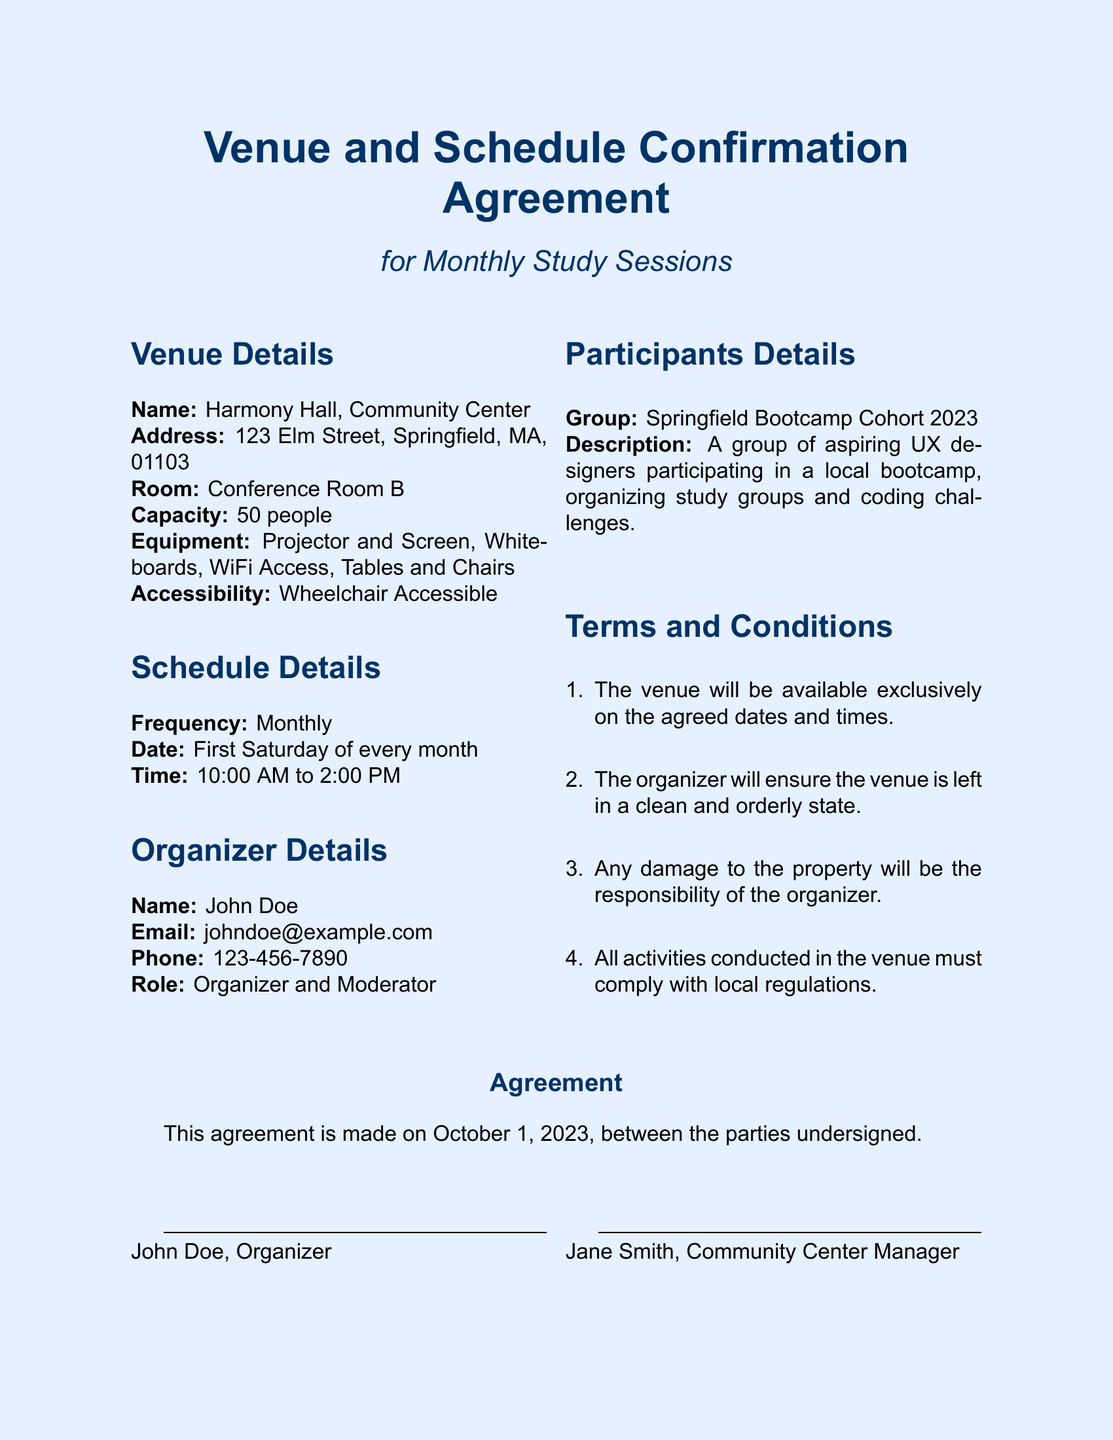What is the name of the venue? The venue name is mentioned in the Venue Details section of the document.
Answer: Harmony Hall What is the address of the venue? The address is specified in the Venue Details section.
Answer: 123 Elm Street, Springfield, MA, 01103 When are the study sessions scheduled? The schedule is detailed in the Schedule Details section, specifying the monthly frequency.
Answer: First Saturday of every month What time do the sessions start? The time is indicated in the Schedule Details section, referring to the start time of the sessions.
Answer: 10:00 AM Who is the organizer of the study sessions? The organizer's name is listed in the Organizer Details section.
Answer: John Doe What is the capacity of the venue? The capacity is mentioned in the Venue Details section regarding the number of people it can accommodate.
Answer: 50 people What email address is provided for the organizer? The email of the organizer is indicated in the Organizer Details section.
Answer: johndoe@example.com How will damages to the property be handled? This is explained in the Terms and Conditions section regarding the responsibility for damage.
Answer: Responsibility of the organizer On what date was the agreement made? The date of the agreement is specified at the bottom of the document.
Answer: October 1, 2023 